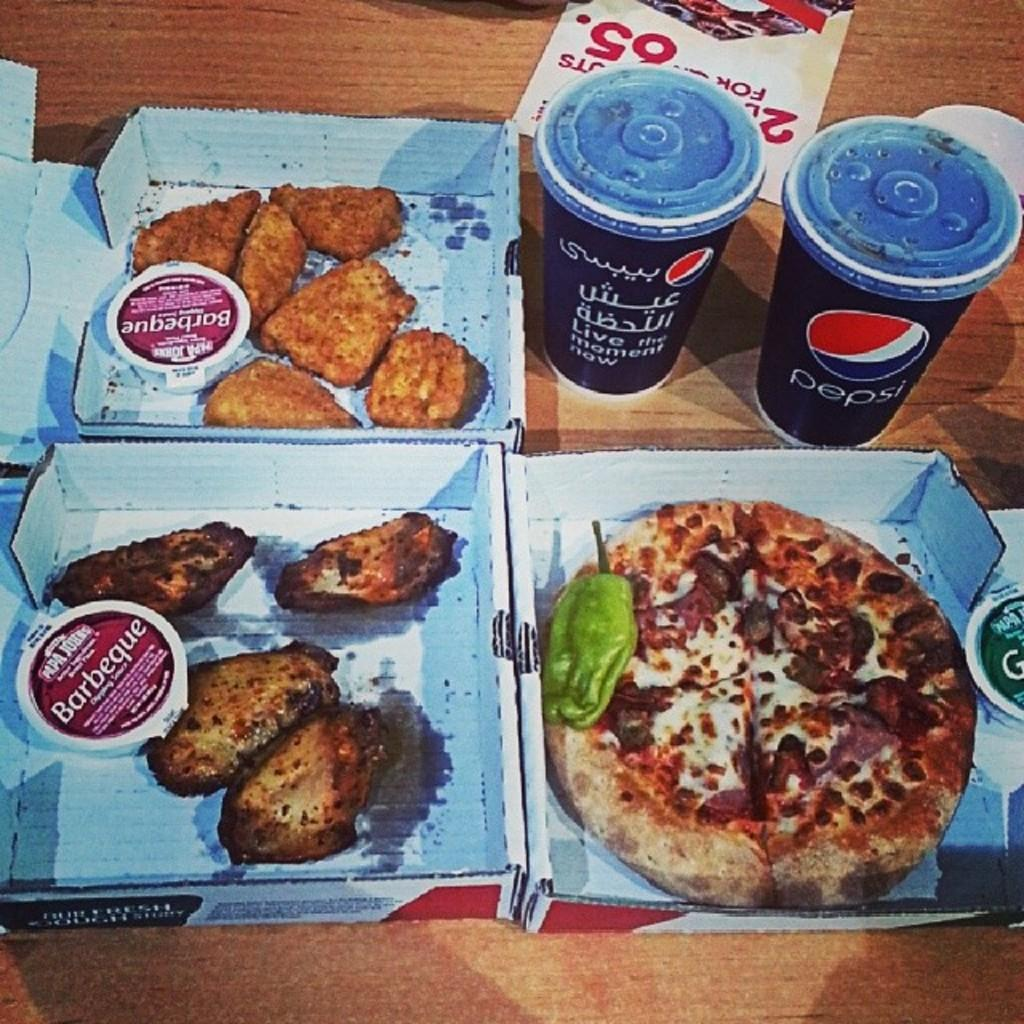What type of food items are in boxes on the left side of the image? The fact does not specify the type of food items in the boxes. What is the main food item on the right side of the image? There is a pizza on the right side of the image. What type of glasses are at the top of the image? There are Pepsi glasses at the top of the image. What type of teeth can be seen in the image? There are no teeth present in the image. What kind of cloud is visible in the image? There is no cloud visible in the image. 